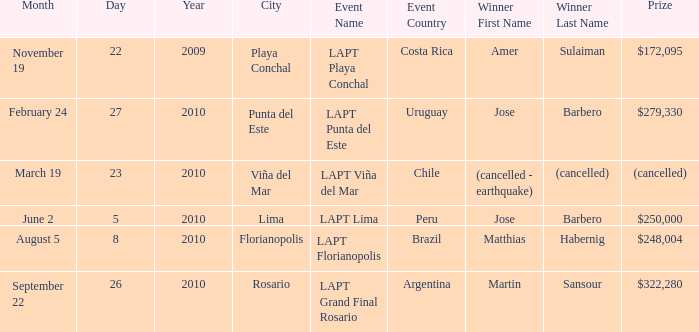What occurrence features a $248,004 reward? LAPT Florianopolis - Brazil. 